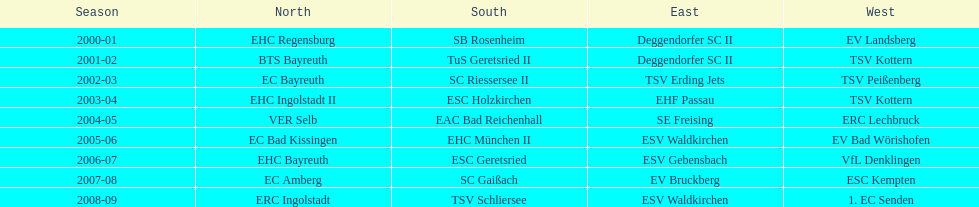Would you be able to parse every entry in this table? {'header': ['Season', 'North', 'South', 'East', 'West'], 'rows': [['2000-01', 'EHC Regensburg', 'SB Rosenheim', 'Deggendorfer SC II', 'EV Landsberg'], ['2001-02', 'BTS Bayreuth', 'TuS Geretsried II', 'Deggendorfer SC II', 'TSV Kottern'], ['2002-03', 'EC Bayreuth', 'SC Riessersee II', 'TSV Erding Jets', 'TSV Peißenberg'], ['2003-04', 'EHC Ingolstadt II', 'ESC Holzkirchen', 'EHF Passau', 'TSV Kottern'], ['2004-05', 'VER Selb', 'EAC Bad Reichenhall', 'SE Freising', 'ERC Lechbruck'], ['2005-06', 'EC Bad Kissingen', 'EHC München II', 'ESV Waldkirchen', 'EV Bad Wörishofen'], ['2006-07', 'EHC Bayreuth', 'ESC Geretsried', 'ESV Gebensbach', 'VfL Denklingen'], ['2007-08', 'EC Amberg', 'SC Gaißach', 'EV Bruckberg', 'ESC Kempten'], ['2008-09', 'ERC Ingolstadt', 'TSV Schliersee', 'ESV Waldkirchen', '1. EC Senden']]} What is the number of seasons covered in the table? 9. 